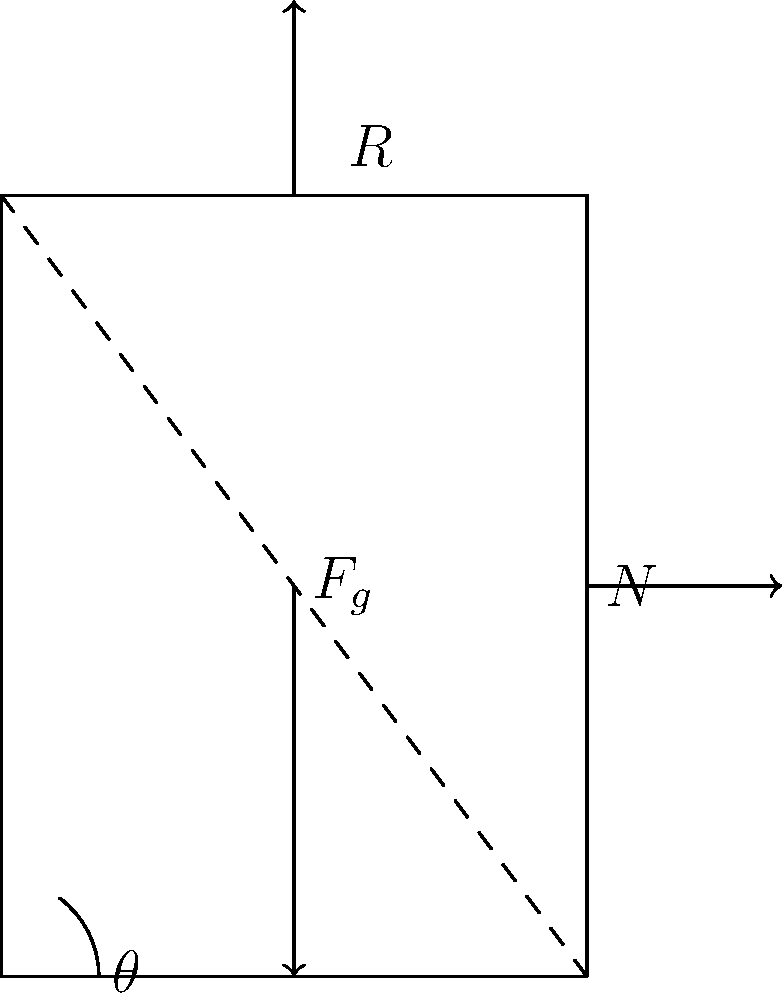In a reclining chair mechanism, as shown in the force diagram, what is the relationship between the gravitational force ($F_g$), the normal force ($N$), and the reaction force ($R$) when the chair is in equilibrium? Express your answer in terms of these forces and the angle $\theta$. To understand the relationship between the forces in the reclining chair mechanism, we'll follow these steps:

1. Identify the forces:
   - $F_g$: Gravitational force (weight of the person)
   - $N$: Normal force from the floor
   - $R$: Reaction force from the backrest

2. Recognize that for the chair to be in equilibrium, the sum of all forces must be zero in both x and y directions.

3. Resolve forces into x and y components:
   - $F_g$ is already in the y-direction (negative)
   - $N$ is in the x-direction (positive)
   - $R$ needs to be resolved:
     $R_x = R \sin\theta$ (negative x-direction)
     $R_y = R \cos\theta$ (positive y-direction)

4. Set up equilibrium equations:
   For x-direction: $N - R \sin\theta = 0$
   For y-direction: $R \cos\theta - F_g = 0$

5. From the y-direction equation:
   $R \cos\theta = F_g$
   $R = \frac{F_g}{\cos\theta}$

6. Substitute this into the x-direction equation:
   $N - \frac{F_g}{\cos\theta} \sin\theta = 0$
   $N = F_g \tan\theta$

7. The relationship between the forces can be expressed as:
   $N = F_g \tan\theta$ and $R = \frac{F_g}{\cos\theta}$

This relationship shows how the normal force and reaction force depend on the gravitational force and the angle of the chair's backrest.
Answer: $N = F_g \tan\theta$, $R = \frac{F_g}{\cos\theta}$ 